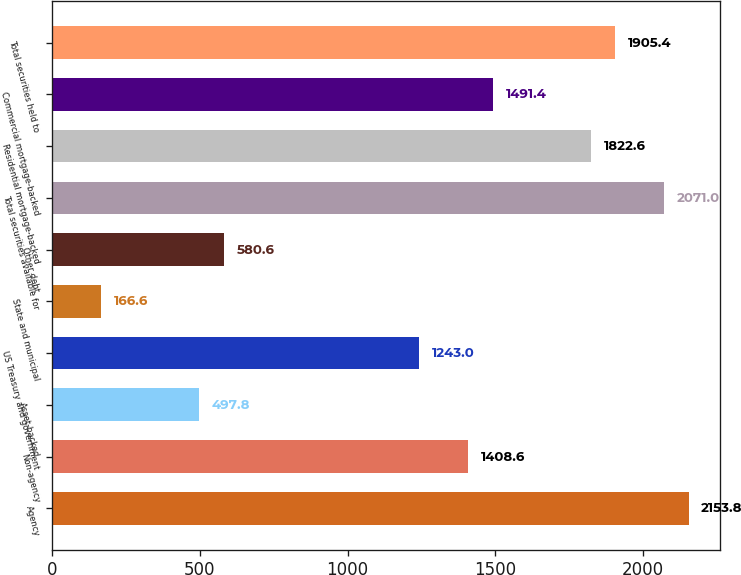Convert chart to OTSL. <chart><loc_0><loc_0><loc_500><loc_500><bar_chart><fcel>Agency<fcel>Non-agency<fcel>Asset-backed<fcel>US Treasury and government<fcel>State and municipal<fcel>Other debt<fcel>Total securities available for<fcel>Residential mortgage-backed<fcel>Commercial mortgage-backed<fcel>Total securities held to<nl><fcel>2153.8<fcel>1408.6<fcel>497.8<fcel>1243<fcel>166.6<fcel>580.6<fcel>2071<fcel>1822.6<fcel>1491.4<fcel>1905.4<nl></chart> 